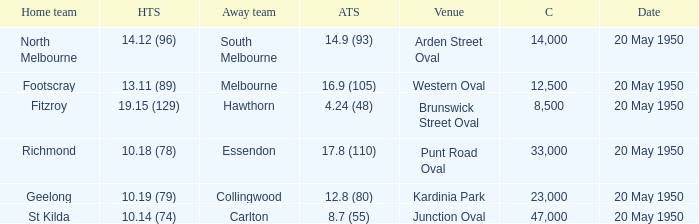What was the score for the away team that played against Richmond and has a crowd over 12,500? 17.8 (110). 